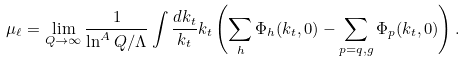Convert formula to latex. <formula><loc_0><loc_0><loc_500><loc_500>\mu _ { \ell } = \lim _ { Q \to \infty } \frac { 1 } { \ln ^ { A } Q / \Lambda } \int \frac { d k _ { t } } { k _ { t } } k _ { t } \left ( \sum _ { h } \Phi _ { h } ( k _ { t } , 0 ) - \sum _ { p = q , g } \Phi _ { p } ( k _ { t } , 0 ) \right ) .</formula> 